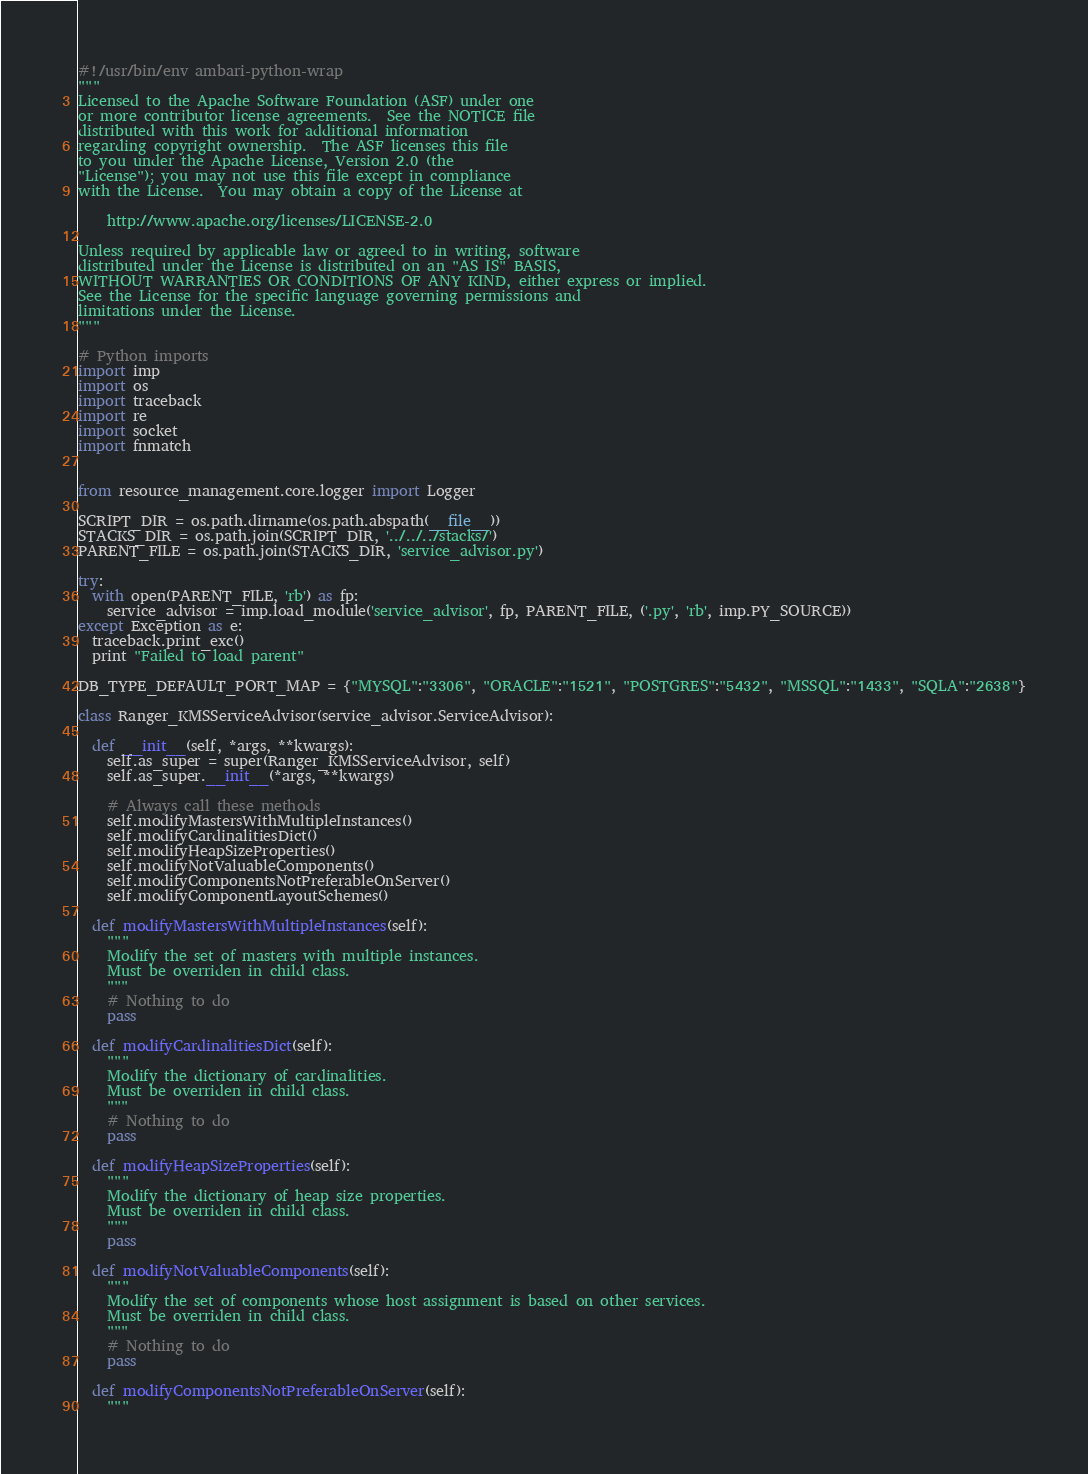Convert code to text. <code><loc_0><loc_0><loc_500><loc_500><_Python_>#!/usr/bin/env ambari-python-wrap
"""
Licensed to the Apache Software Foundation (ASF) under one
or more contributor license agreements.  See the NOTICE file
distributed with this work for additional information
regarding copyright ownership.  The ASF licenses this file
to you under the Apache License, Version 2.0 (the
"License"); you may not use this file except in compliance
with the License.  You may obtain a copy of the License at

    http://www.apache.org/licenses/LICENSE-2.0

Unless required by applicable law or agreed to in writing, software
distributed under the License is distributed on an "AS IS" BASIS,
WITHOUT WARRANTIES OR CONDITIONS OF ANY KIND, either express or implied.
See the License for the specific language governing permissions and
limitations under the License.
"""

# Python imports
import imp
import os
import traceback
import re
import socket
import fnmatch


from resource_management.core.logger import Logger

SCRIPT_DIR = os.path.dirname(os.path.abspath(__file__))
STACKS_DIR = os.path.join(SCRIPT_DIR, '../../../stacks/')
PARENT_FILE = os.path.join(STACKS_DIR, 'service_advisor.py')

try:
  with open(PARENT_FILE, 'rb') as fp:
    service_advisor = imp.load_module('service_advisor', fp, PARENT_FILE, ('.py', 'rb', imp.PY_SOURCE))
except Exception as e:
  traceback.print_exc()
  print "Failed to load parent"

DB_TYPE_DEFAULT_PORT_MAP = {"MYSQL":"3306", "ORACLE":"1521", "POSTGRES":"5432", "MSSQL":"1433", "SQLA":"2638"}

class Ranger_KMSServiceAdvisor(service_advisor.ServiceAdvisor):

  def __init__(self, *args, **kwargs):
    self.as_super = super(Ranger_KMSServiceAdvisor, self)
    self.as_super.__init__(*args, **kwargs)

    # Always call these methods
    self.modifyMastersWithMultipleInstances()
    self.modifyCardinalitiesDict()
    self.modifyHeapSizeProperties()
    self.modifyNotValuableComponents()
    self.modifyComponentsNotPreferableOnServer()
    self.modifyComponentLayoutSchemes()

  def modifyMastersWithMultipleInstances(self):
    """
    Modify the set of masters with multiple instances.
    Must be overriden in child class.
    """
    # Nothing to do
    pass

  def modifyCardinalitiesDict(self):
    """
    Modify the dictionary of cardinalities.
    Must be overriden in child class.
    """
    # Nothing to do
    pass

  def modifyHeapSizeProperties(self):
    """
    Modify the dictionary of heap size properties.
    Must be overriden in child class.
    """
    pass

  def modifyNotValuableComponents(self):
    """
    Modify the set of components whose host assignment is based on other services.
    Must be overriden in child class.
    """
    # Nothing to do
    pass

  def modifyComponentsNotPreferableOnServer(self):
    """</code> 